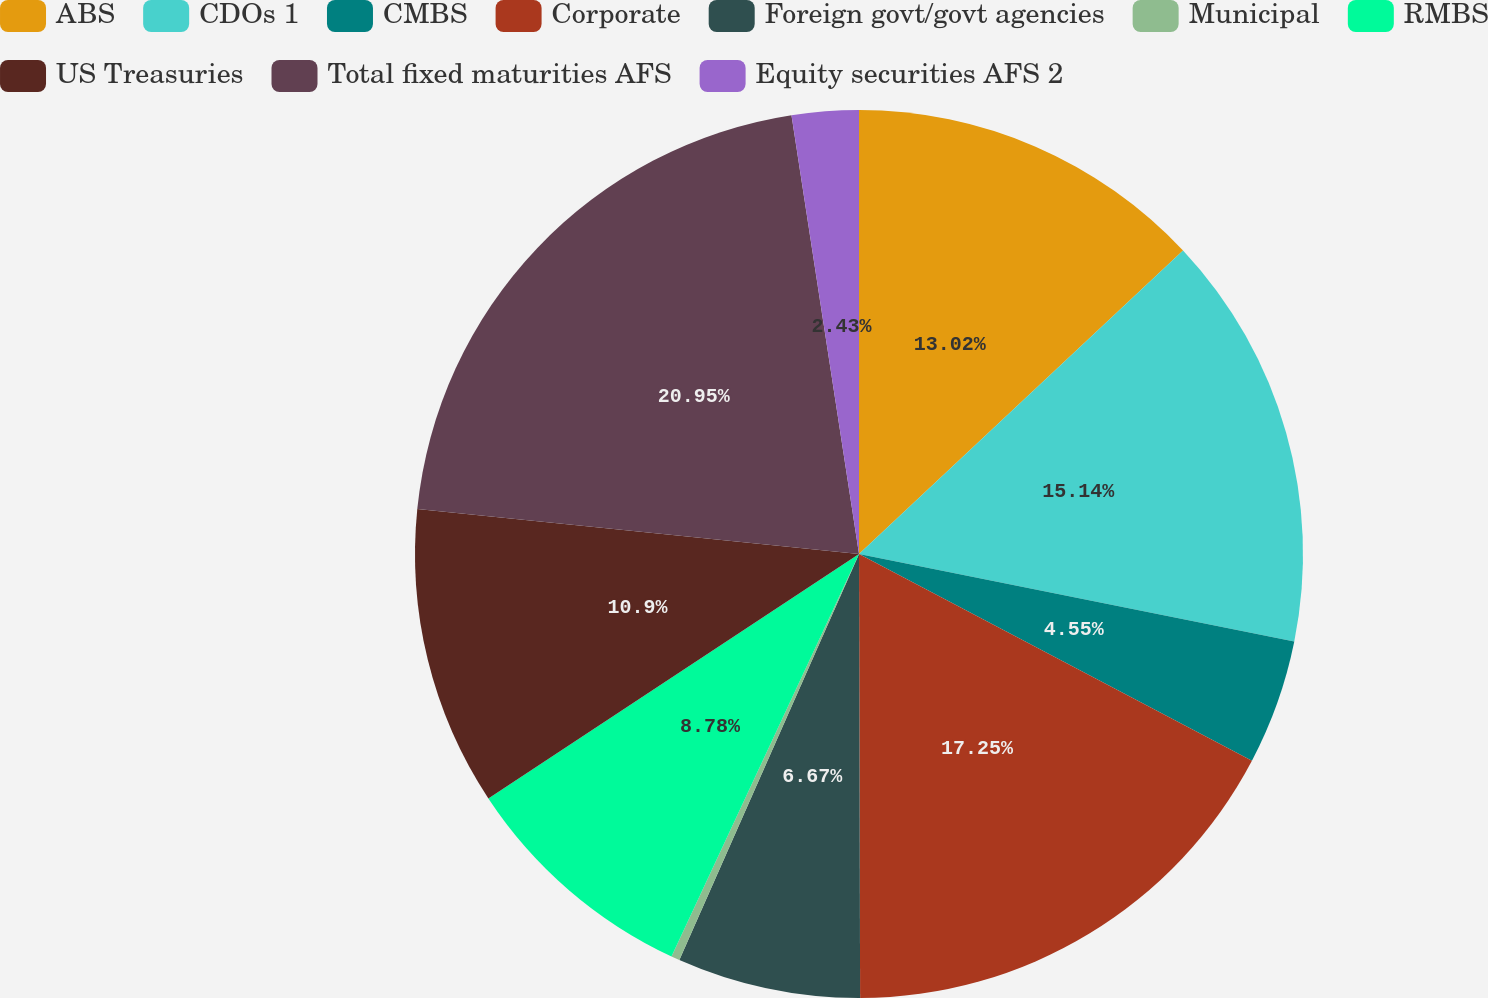<chart> <loc_0><loc_0><loc_500><loc_500><pie_chart><fcel>ABS<fcel>CDOs 1<fcel>CMBS<fcel>Corporate<fcel>Foreign govt/govt agencies<fcel>Municipal<fcel>RMBS<fcel>US Treasuries<fcel>Total fixed maturities AFS<fcel>Equity securities AFS 2<nl><fcel>13.02%<fcel>15.14%<fcel>4.55%<fcel>17.25%<fcel>6.67%<fcel>0.31%<fcel>8.78%<fcel>10.9%<fcel>20.95%<fcel>2.43%<nl></chart> 